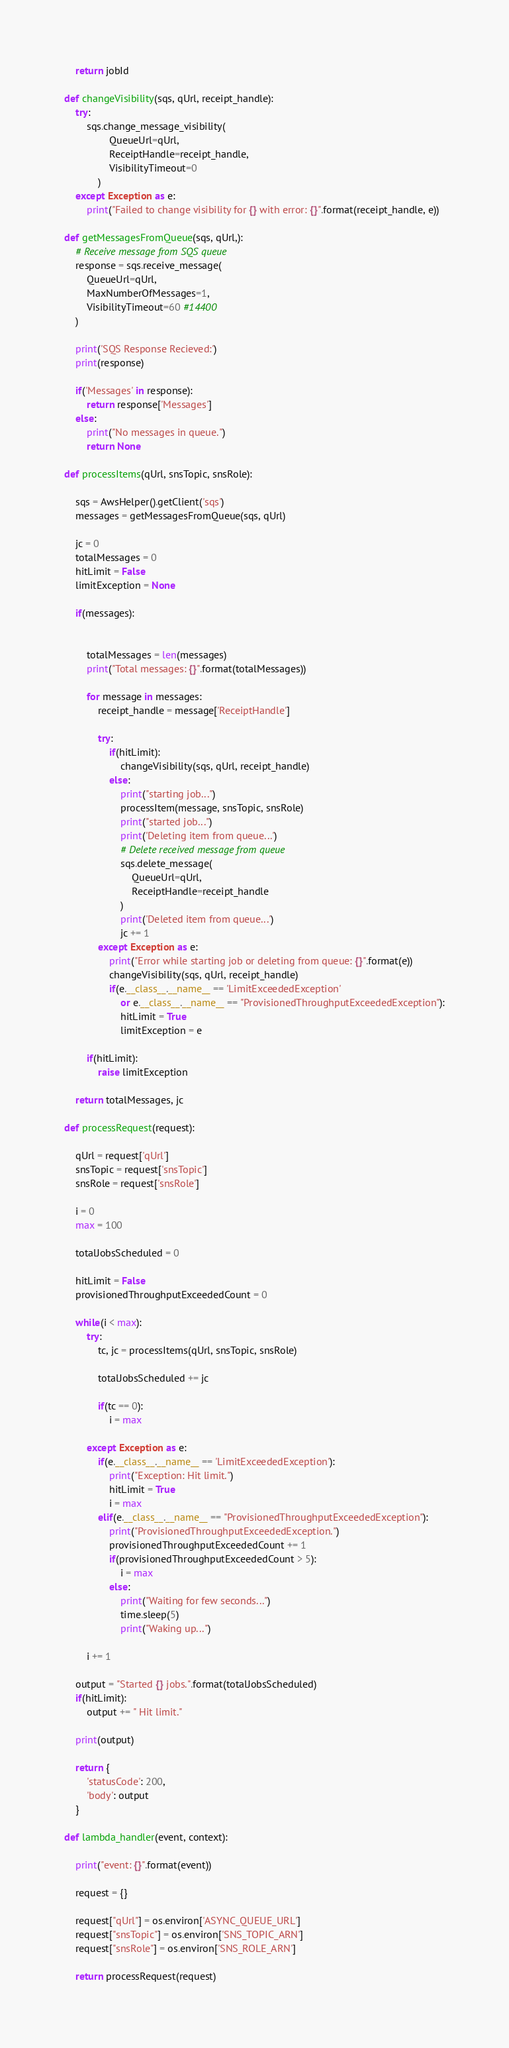<code> <loc_0><loc_0><loc_500><loc_500><_Python_>    return jobId

def changeVisibility(sqs, qUrl, receipt_handle):
    try:
        sqs.change_message_visibility(
                QueueUrl=qUrl,
                ReceiptHandle=receipt_handle,
                VisibilityTimeout=0
            )
    except Exception as e:
        print("Failed to change visibility for {} with error: {}".format(receipt_handle, e))

def getMessagesFromQueue(sqs, qUrl,):
    # Receive message from SQS queue
    response = sqs.receive_message(
        QueueUrl=qUrl,
        MaxNumberOfMessages=1,
        VisibilityTimeout=60 #14400
    )

    print('SQS Response Recieved:')
    print(response)

    if('Messages' in response):
        return response['Messages']
    else:
        print("No messages in queue.")
        return None

def processItems(qUrl, snsTopic, snsRole):

    sqs = AwsHelper().getClient('sqs')
    messages = getMessagesFromQueue(sqs, qUrl)

    jc = 0
    totalMessages = 0
    hitLimit = False
    limitException = None

    if(messages):


        totalMessages = len(messages)
        print("Total messages: {}".format(totalMessages))

        for message in messages:
            receipt_handle = message['ReceiptHandle']

            try:
                if(hitLimit):
                    changeVisibility(sqs, qUrl, receipt_handle)
                else:
                    print("starting job...")
                    processItem(message, snsTopic, snsRole)
                    print("started job...")
                    print('Deleting item from queue...')
                    # Delete received message from queue
                    sqs.delete_message(
                        QueueUrl=qUrl,
                        ReceiptHandle=receipt_handle
                    )
                    print('Deleted item from queue...')
                    jc += 1
            except Exception as e:
                print("Error while starting job or deleting from queue: {}".format(e))
                changeVisibility(sqs, qUrl, receipt_handle)
                if(e.__class__.__name__ == 'LimitExceededException' 
                    or e.__class__.__name__ == "ProvisionedThroughputExceededException"):
                    hitLimit = True
                    limitException = e

        if(hitLimit):
            raise limitException

    return totalMessages, jc

def processRequest(request):

    qUrl = request['qUrl']
    snsTopic = request['snsTopic']
    snsRole = request['snsRole']

    i = 0
    max = 100

    totalJobsScheduled = 0

    hitLimit = False
    provisionedThroughputExceededCount = 0

    while(i < max):
        try:
            tc, jc = processItems(qUrl, snsTopic, snsRole)

            totalJobsScheduled += jc

            if(tc == 0):
                i = max

        except Exception as e:
            if(e.__class__.__name__ == 'LimitExceededException'):
                print("Exception: Hit limit.")
                hitLimit = True
                i = max
            elif(e.__class__.__name__ == "ProvisionedThroughputExceededException"):
                print("ProvisionedThroughputExceededException.")
                provisionedThroughputExceededCount += 1
                if(provisionedThroughputExceededCount > 5):
                    i = max
                else:
                    print("Waiting for few seconds...")
                    time.sleep(5)
                    print("Waking up...")

        i += 1

    output = "Started {} jobs.".format(totalJobsScheduled)
    if(hitLimit):
        output += " Hit limit."

    print(output)

    return {
        'statusCode': 200,
        'body': output
    }

def lambda_handler(event, context):

    print("event: {}".format(event))

    request = {}

    request["qUrl"] = os.environ['ASYNC_QUEUE_URL']
    request["snsTopic"] = os.environ['SNS_TOPIC_ARN']
    request["snsRole"] = os.environ['SNS_ROLE_ARN']

    return processRequest(request)
</code> 